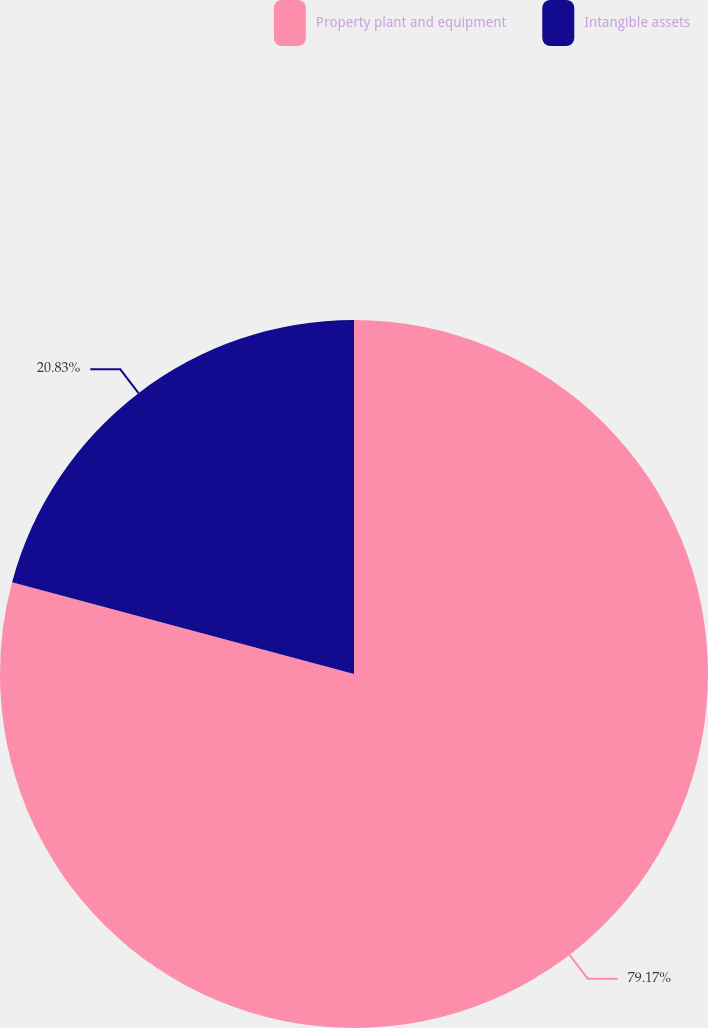Convert chart to OTSL. <chart><loc_0><loc_0><loc_500><loc_500><pie_chart><fcel>Property plant and equipment<fcel>Intangible assets<nl><fcel>79.17%<fcel>20.83%<nl></chart> 